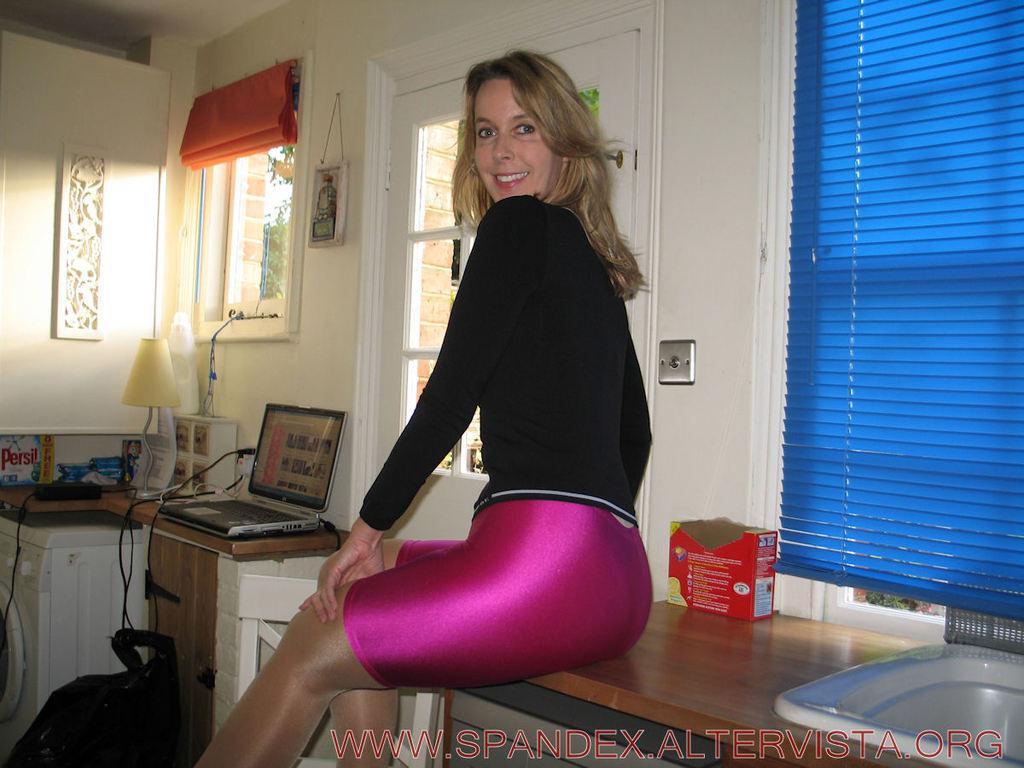Describe this image in one or two sentences. This is an inside view of a room. In the middle of the image there is a woman sitting on a table facing towards the left side and smiling by looking at the picture. On this table there is a box and there is a sink. On the left side there is a table on which a laptop, lamp, a box, cables and some other objects are placed. Beside the table there is a bag placed on the floor. In the background, I can see two windows and a door. 